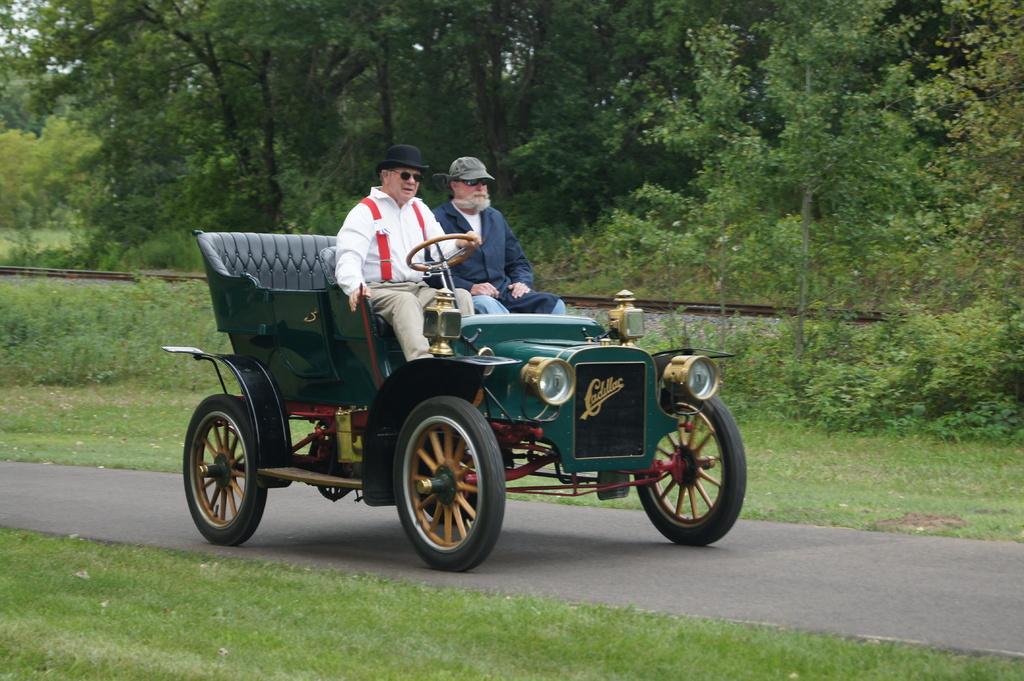How would you summarize this image in a sentence or two? This picture shows two men moving in a car on the road we see trees around 